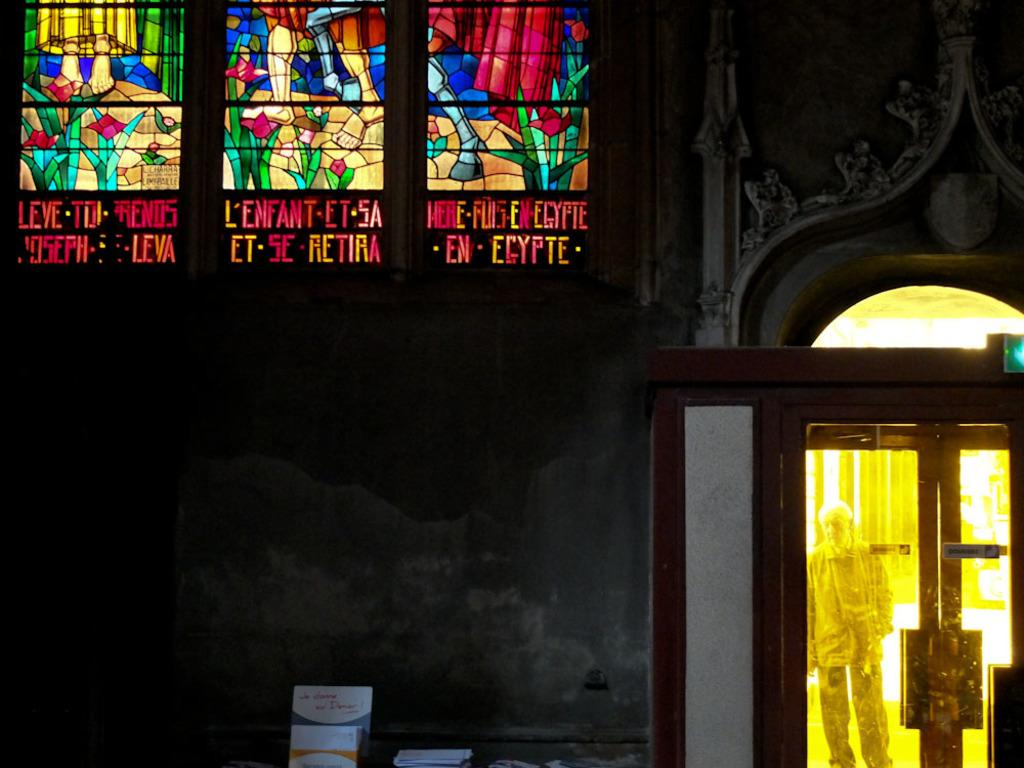What can be seen in the image? There are objects and a wall in the image. Are there any architectural features visible in the image? Yes, there are doors in the image. Can you describe the man in the image? A man is standing in the image, visible through a door. What type of ring is the boy wearing in the image? There is no boy present in the image, and therefore no ring can be observed. 